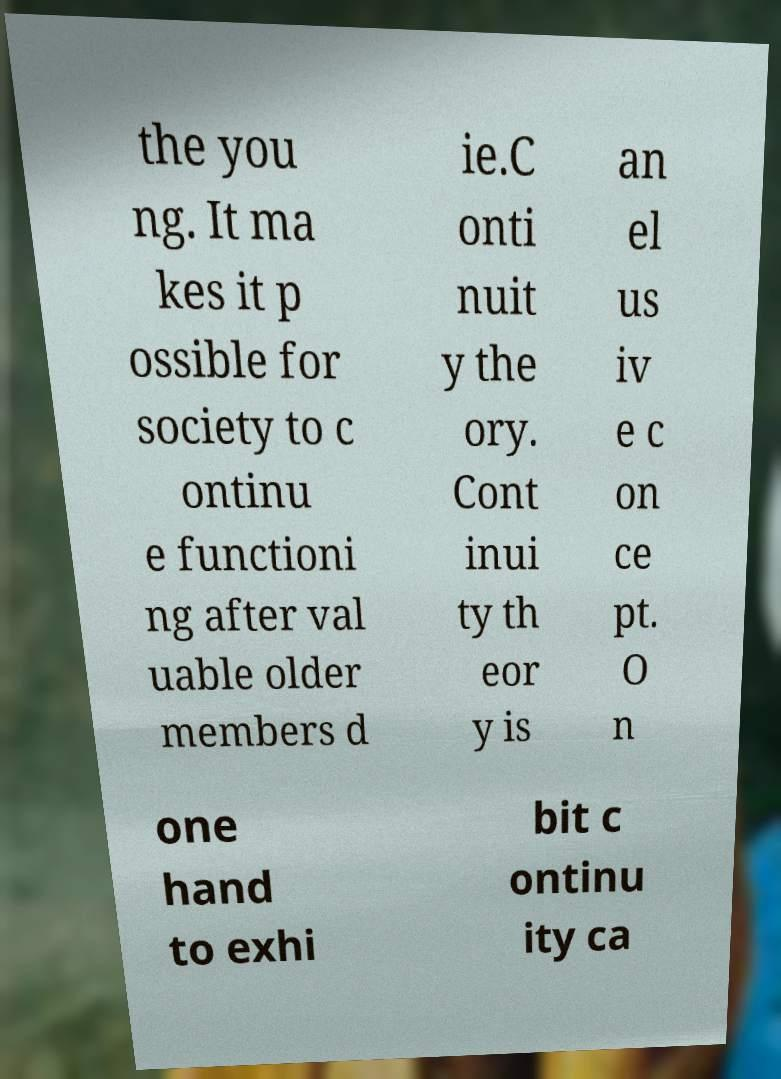Please read and relay the text visible in this image. What does it say? the you ng. It ma kes it p ossible for society to c ontinu e functioni ng after val uable older members d ie.C onti nuit y the ory. Cont inui ty th eor y is an el us iv e c on ce pt. O n one hand to exhi bit c ontinu ity ca 